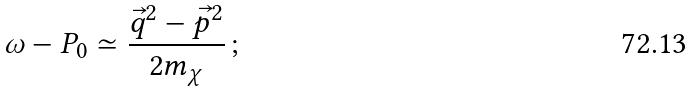<formula> <loc_0><loc_0><loc_500><loc_500>\omega - P _ { 0 } \simeq \frac { \vec { q } ^ { 2 } - \vec { p } ^ { 2 } } { 2 m _ { \chi } } \, ;</formula> 